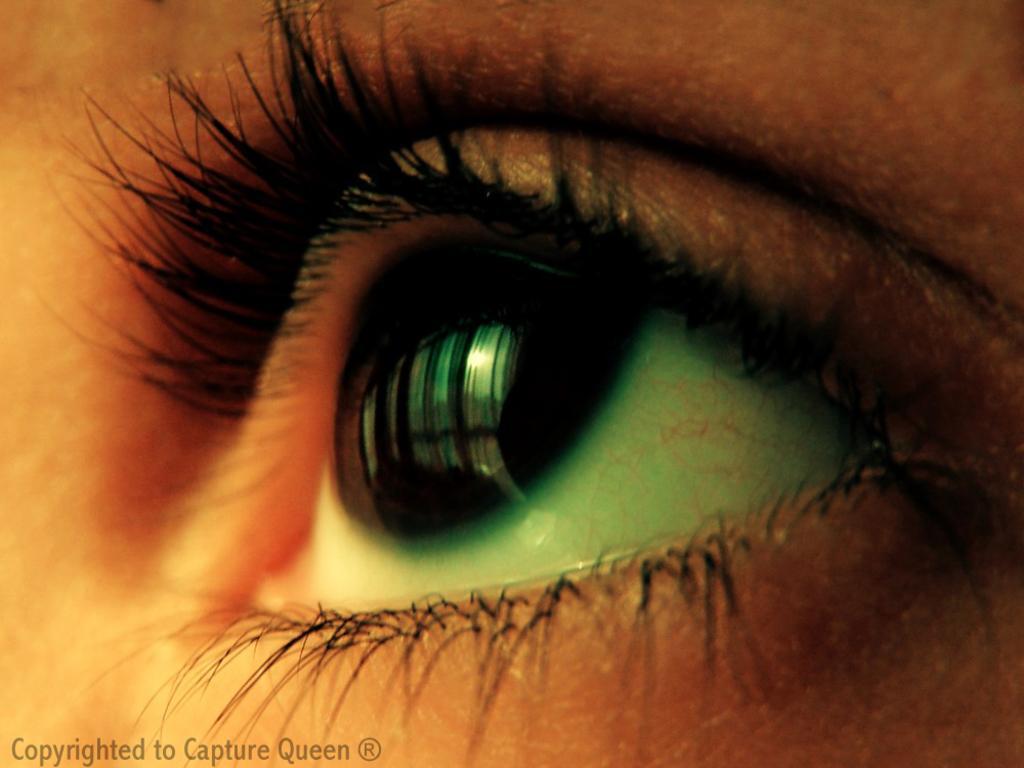Please provide a concise description of this image. In this picture I can see an eye of a person, and there is a watermark on the image. 